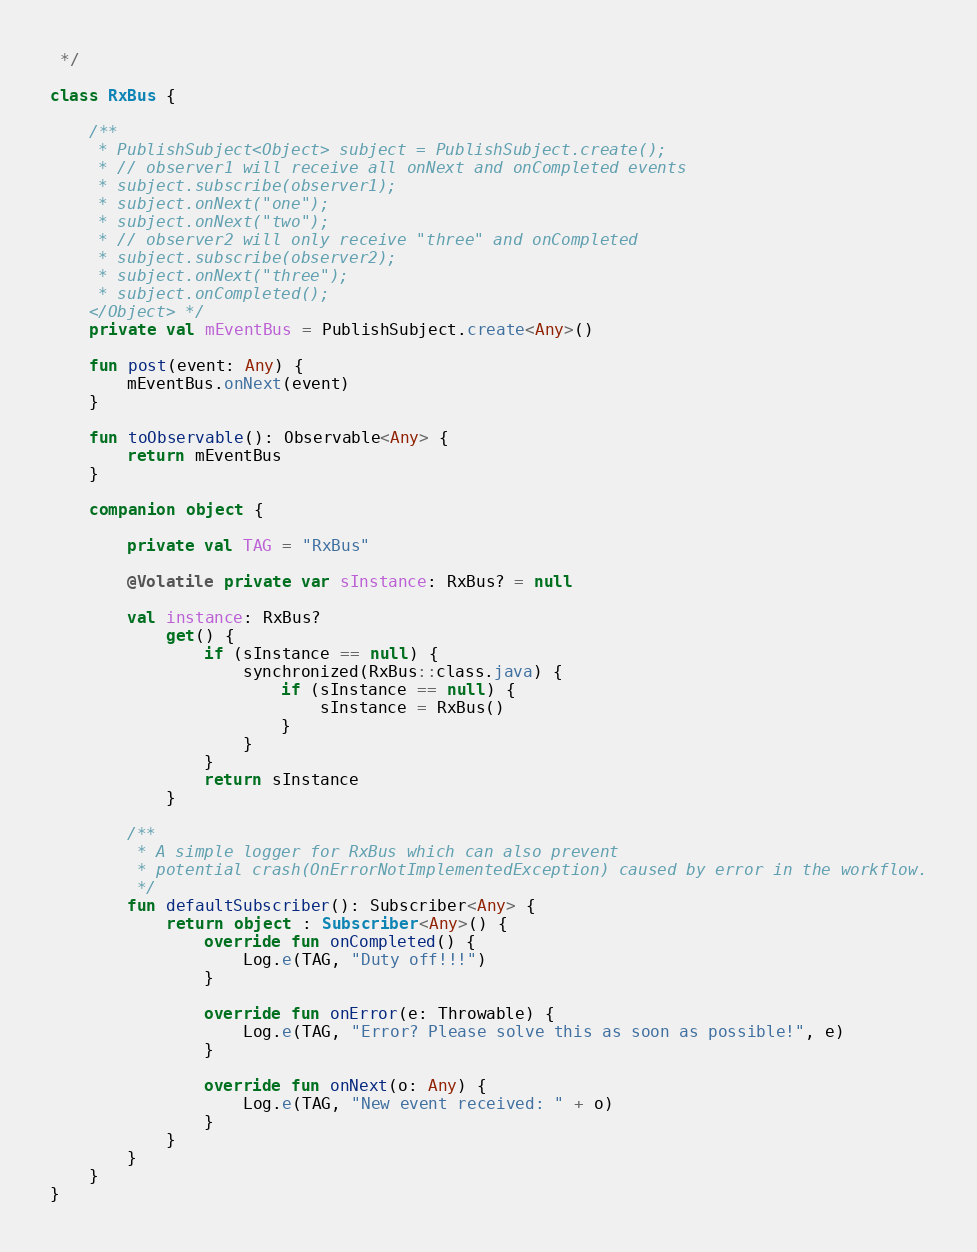Convert code to text. <code><loc_0><loc_0><loc_500><loc_500><_Kotlin_> */

class RxBus {

    /**
     * PublishSubject<Object> subject = PublishSubject.create();
     * // observer1 will receive all onNext and onCompleted events
     * subject.subscribe(observer1);
     * subject.onNext("one");
     * subject.onNext("two");
     * // observer2 will only receive "three" and onCompleted
     * subject.subscribe(observer2);
     * subject.onNext("three");
     * subject.onCompleted();
    </Object> */
    private val mEventBus = PublishSubject.create<Any>()

    fun post(event: Any) {
        mEventBus.onNext(event)
    }

    fun toObservable(): Observable<Any> {
        return mEventBus
    }

    companion object {

        private val TAG = "RxBus"

        @Volatile private var sInstance: RxBus? = null

        val instance: RxBus?
            get() {
                if (sInstance == null) {
                    synchronized(RxBus::class.java) {
                        if (sInstance == null) {
                            sInstance = RxBus()
                        }
                    }
                }
                return sInstance
            }

        /**
         * A simple logger for RxBus which can also prevent
         * potential crash(OnErrorNotImplementedException) caused by error in the workflow.
         */
        fun defaultSubscriber(): Subscriber<Any> {
            return object : Subscriber<Any>() {
                override fun onCompleted() {
                    Log.e(TAG, "Duty off!!!")
                }

                override fun onError(e: Throwable) {
                    Log.e(TAG, "Error? Please solve this as soon as possible!", e)
                }

                override fun onNext(o: Any) {
                    Log.e(TAG, "New event received: " + o)
                }
            }
        }
    }
}
</code> 